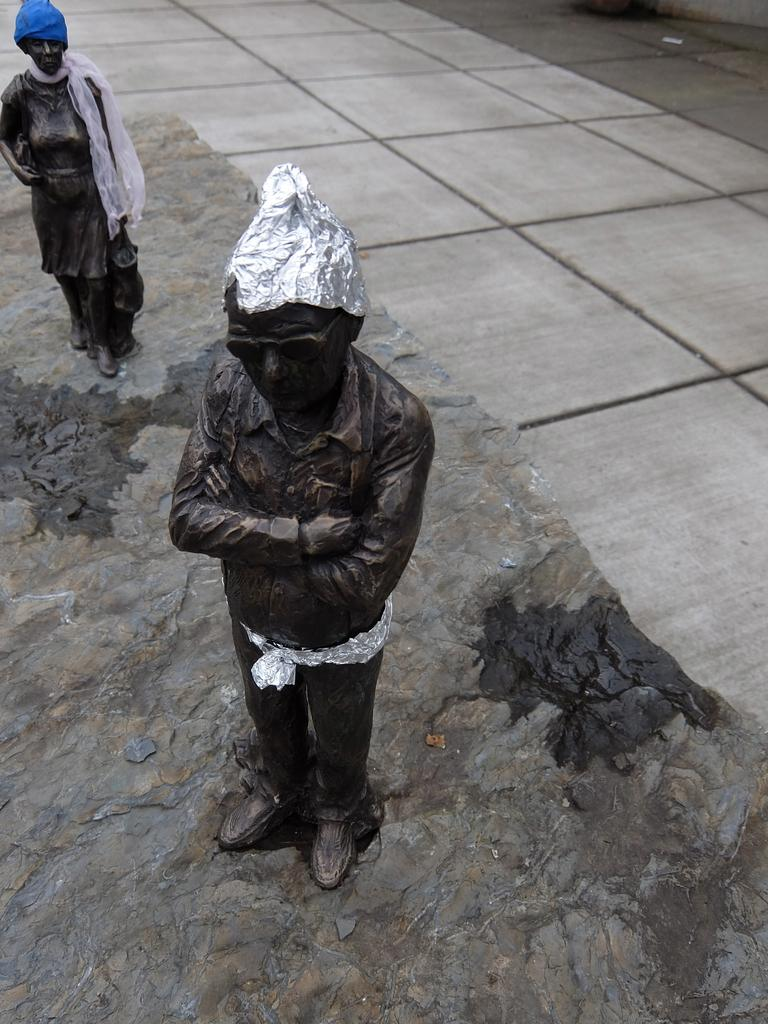What objects are present in the image that resemble people? There are statues in the image. What is on top of the statues? The statues have caps on them. What type of material is visible in the image? There is rock visible in the image. What type of pathway is visible in the image? There is a road visible in the image. Where are the cushions placed in the image? There is no mention of cushions in the image; the image features statues with caps on them, rock, and a road. How many cats can be seen interacting with the statues in the image? There is no mention of cats in the image; the image features statues with caps on them, rock, and a road. 